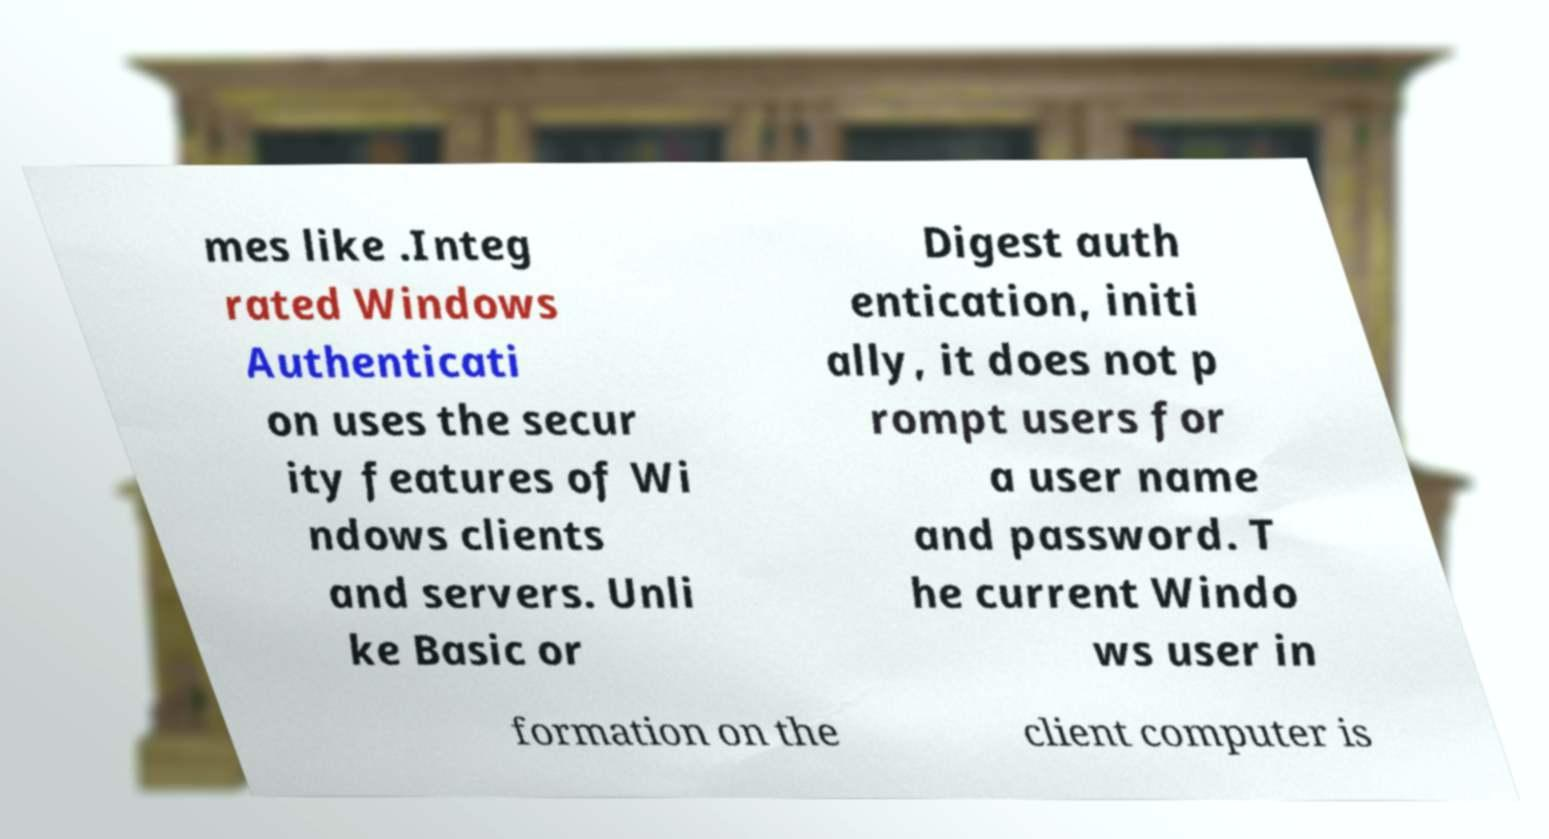For documentation purposes, I need the text within this image transcribed. Could you provide that? mes like .Integ rated Windows Authenticati on uses the secur ity features of Wi ndows clients and servers. Unli ke Basic or Digest auth entication, initi ally, it does not p rompt users for a user name and password. T he current Windo ws user in formation on the client computer is 